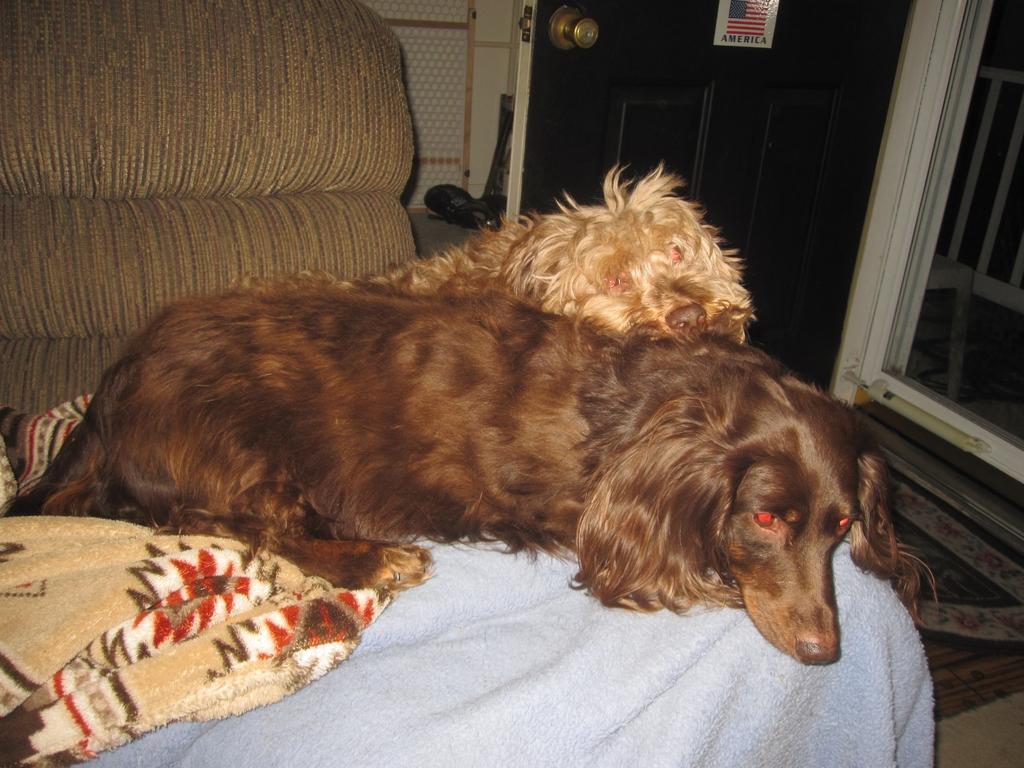In one or two sentences, can you explain what this image depicts? In the center of the image there are two dogs on the couch. In the background of the image there is a door. 